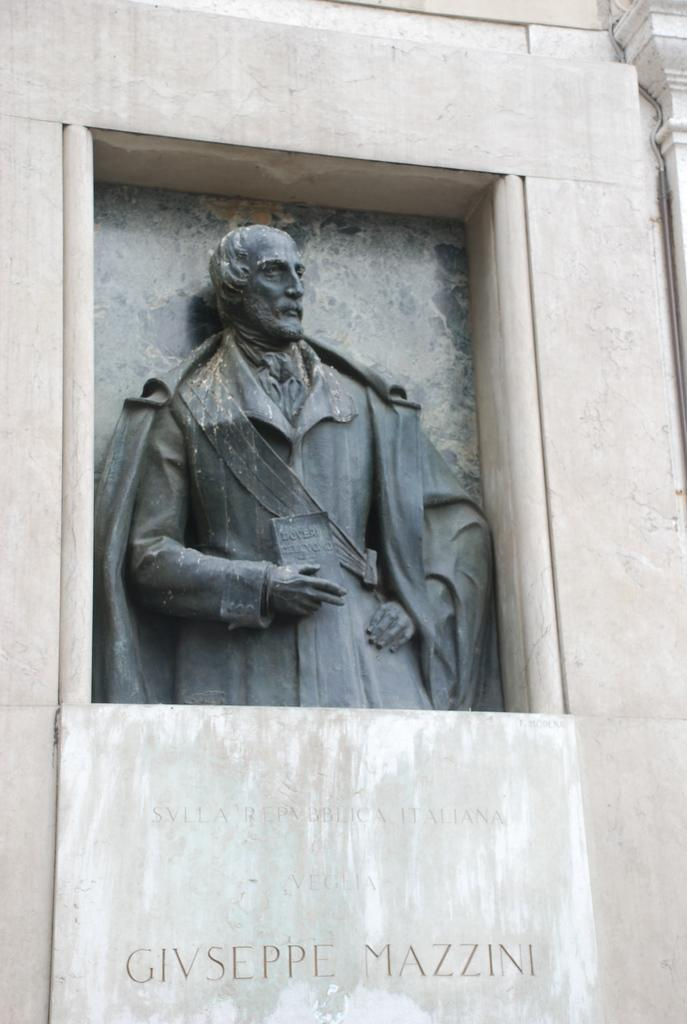Who or what is the main subject of the image? There is a person depicted in the image. Where is the person located in the image? The person is in the middle of a rock structure. What else can be seen in the image besides the person? There is text present in the image. What type of iron is being used by the person in the image? There is no iron present in the image; the person is in the middle of a rock structure. How does the person take notes while climbing the rock structure? The image does not show the person taking notes, nor is there any indication that they are doing so. 